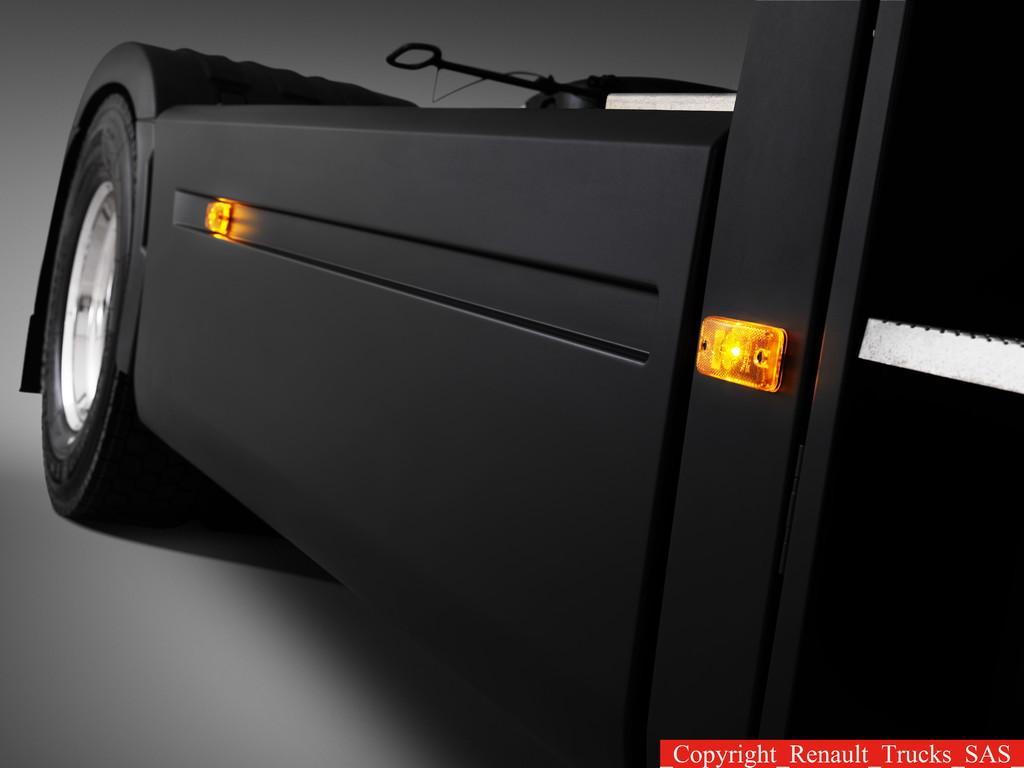Could you give a brief overview of what you see in this image? In this picture, we can see a vehicle, some text in the bottom right corner. 